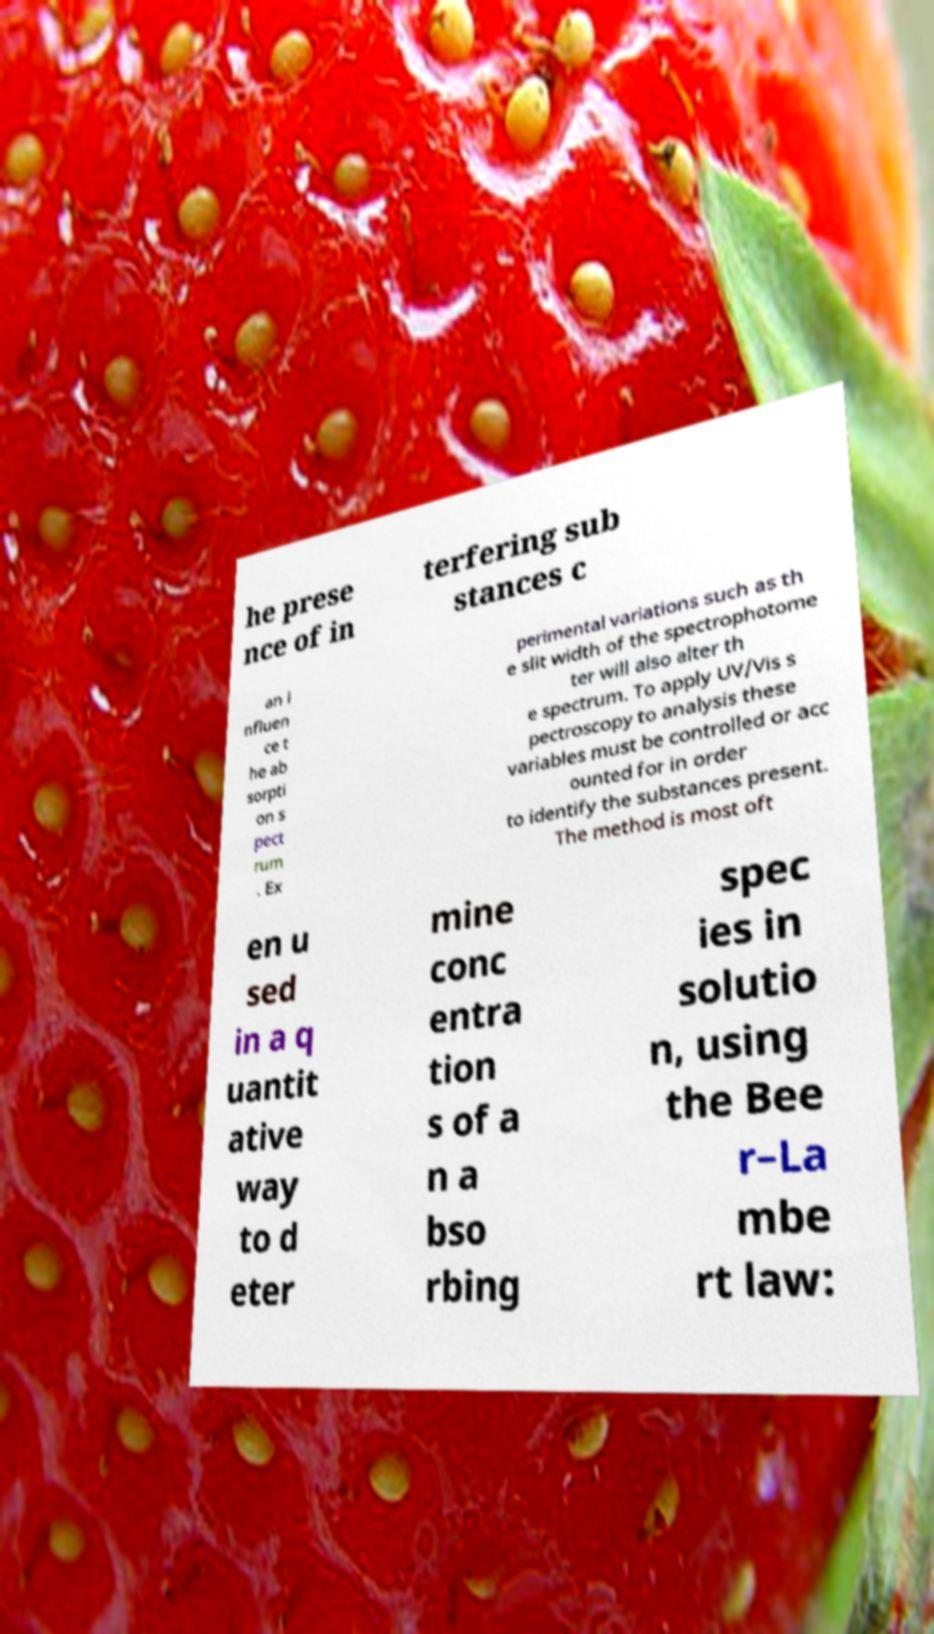Can you accurately transcribe the text from the provided image for me? he prese nce of in terfering sub stances c an i nfluen ce t he ab sorpti on s pect rum . Ex perimental variations such as th e slit width of the spectrophotome ter will also alter th e spectrum. To apply UV/Vis s pectroscopy to analysis these variables must be controlled or acc ounted for in order to identify the substances present. The method is most oft en u sed in a q uantit ative way to d eter mine conc entra tion s of a n a bso rbing spec ies in solutio n, using the Bee r–La mbe rt law: 